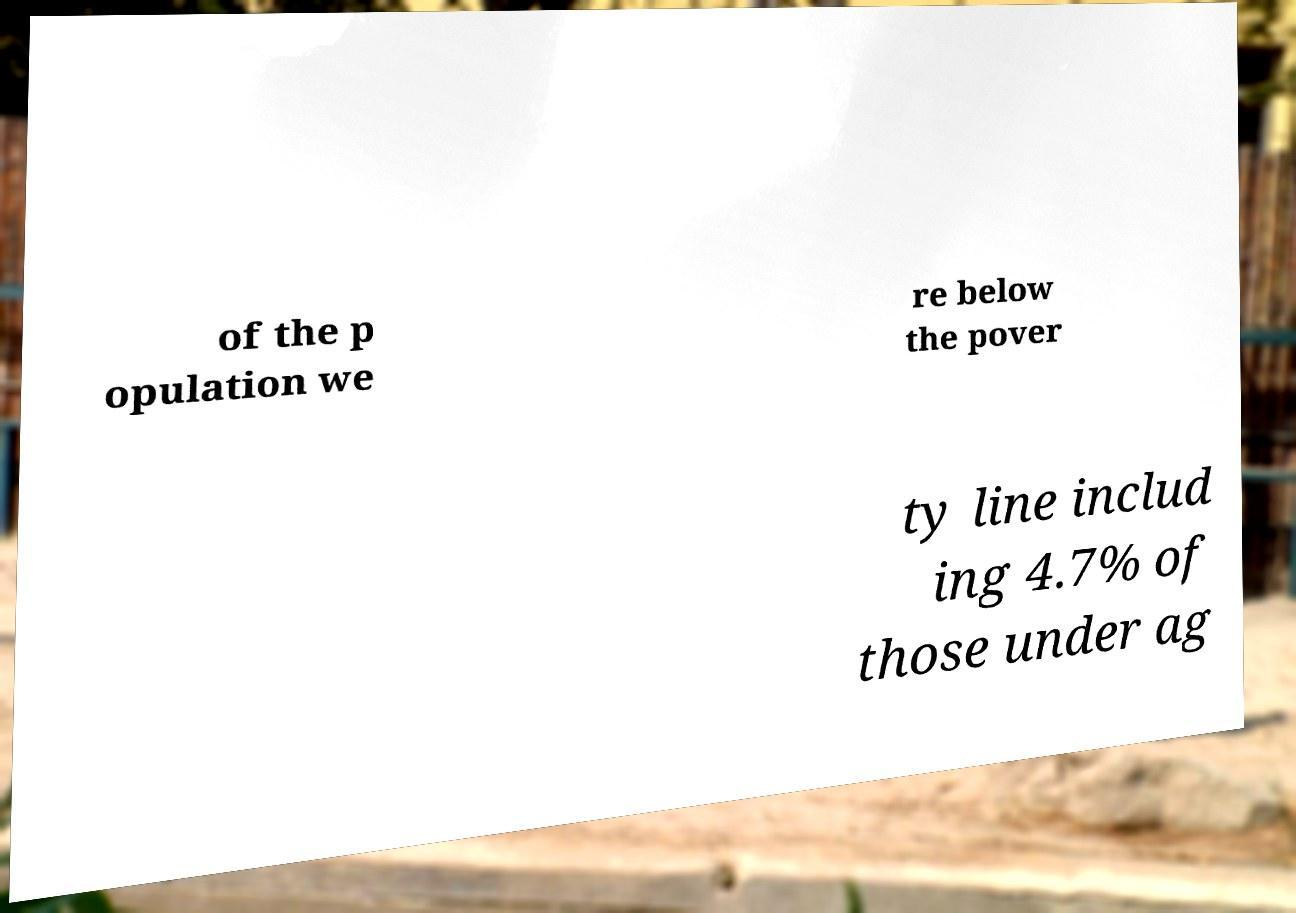Could you assist in decoding the text presented in this image and type it out clearly? of the p opulation we re below the pover ty line includ ing 4.7% of those under ag 